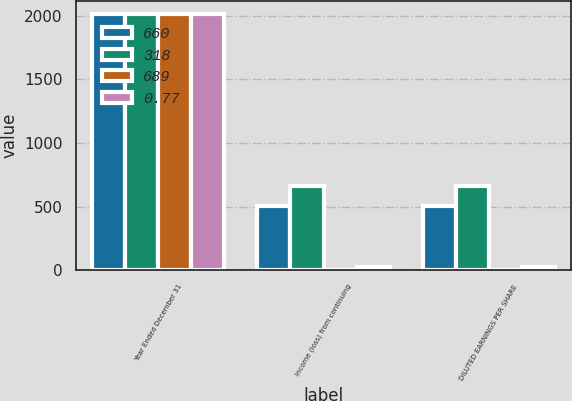Convert chart to OTSL. <chart><loc_0><loc_0><loc_500><loc_500><stacked_bar_chart><ecel><fcel>Year Ended December 31<fcel>Income (loss) from continuing<fcel>DILUTED EARNINGS PER SHARE<nl><fcel>660<fcel>2017<fcel>507<fcel>507<nl><fcel>318<fcel>2017<fcel>660<fcel>660<nl><fcel>689<fcel>2017<fcel>0.77<fcel>0.77<nl><fcel>0.77<fcel>2016<fcel>25<fcel>25<nl></chart> 